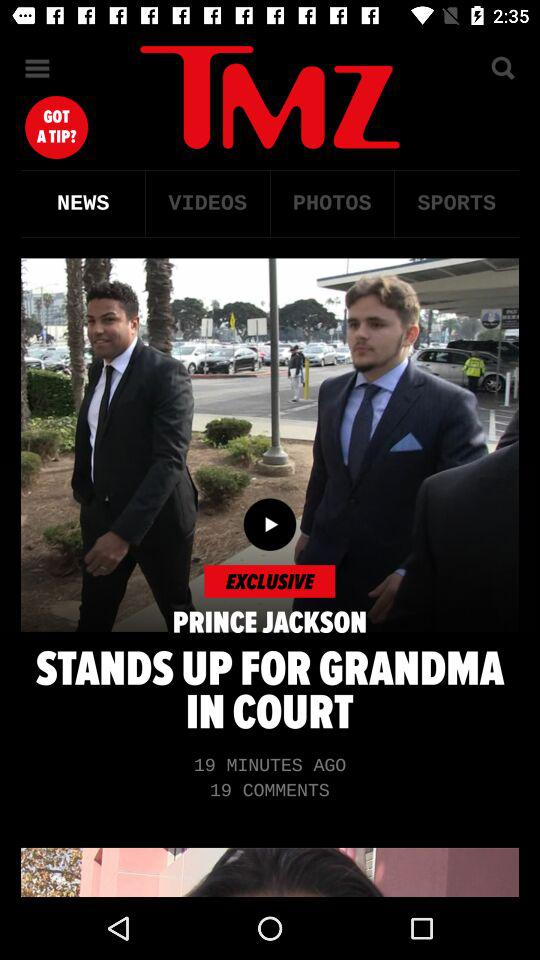What is the count of comments on "STANDS UP FOR GRANDMA IN COURT"? The count of comments is 19. 